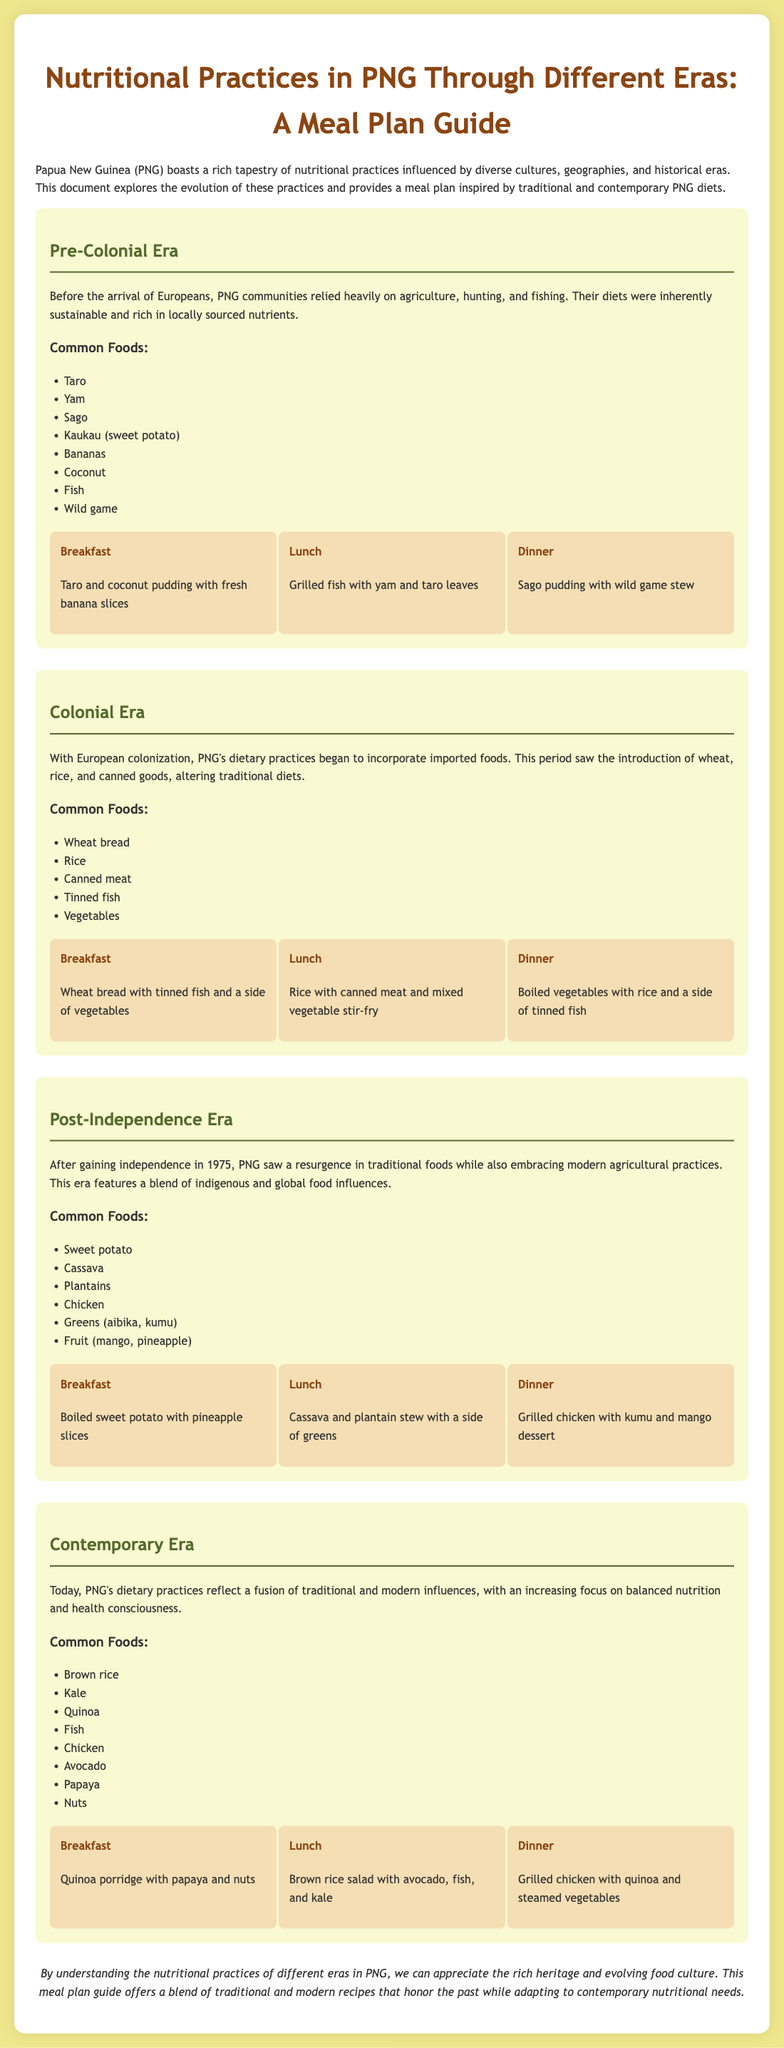What are the common foods in the Pre-Colonial Era? The document lists common foods in the Pre-Colonial Era, including Taro, Yam, Sago, Kaukau, Bananas, Coconut, Fish, and Wild game.
Answer: Taro, Yam, Sago, Kaukau, Bananas, Coconut, Fish, Wild game What is a typical breakfast from the Colonial Era meal plan? The meal plan for the Colonial Era specifies a breakfast of wheat bread with tinned fish and a side of vegetables.
Answer: Wheat bread with tinned fish and a side of vegetables Which food was introduced during the Colonial Era? The document highlights the introduction of wheat, rice, and canned goods during the Colonial Era, altering traditional diets.
Answer: Rice How did dietary practices change after independence in 1975? The document states that after independence in 1975, there was a resurgence in traditional foods while also embracing modern agricultural practices.
Answer: Resurgence in traditional foods What is the typical dinner in the Contemporary Era? The meal plan for the Contemporary Era suggests a dinner of grilled chicken with quinoa and steamed vegetables.
Answer: Grilled chicken with quinoa and steamed vegetables Name one common food in the Post-Independence Era. The document lists common foods including Sweet potato, Cassava, Plantains, and Chicken in the Post-Independence Era.
Answer: Sweet potato What is a unique feature of dietary practices today in PNG? The document indicates that today's dietary practices reflect a fusion of traditional and modern influences, with a focus on balanced nutrition and health consciousness.
Answer: Fusion of traditional and modern influences How many eras are discussed in the document? The document presents information about four different eras of nutritional practices in PNG.
Answer: Four What is suggested for lunch in the Pre-Colonial meal plan? The meal plan for the Pre-Colonial Era includes grilled fish with yam and taro leaves for lunch.
Answer: Grilled fish with yam and taro leaves 